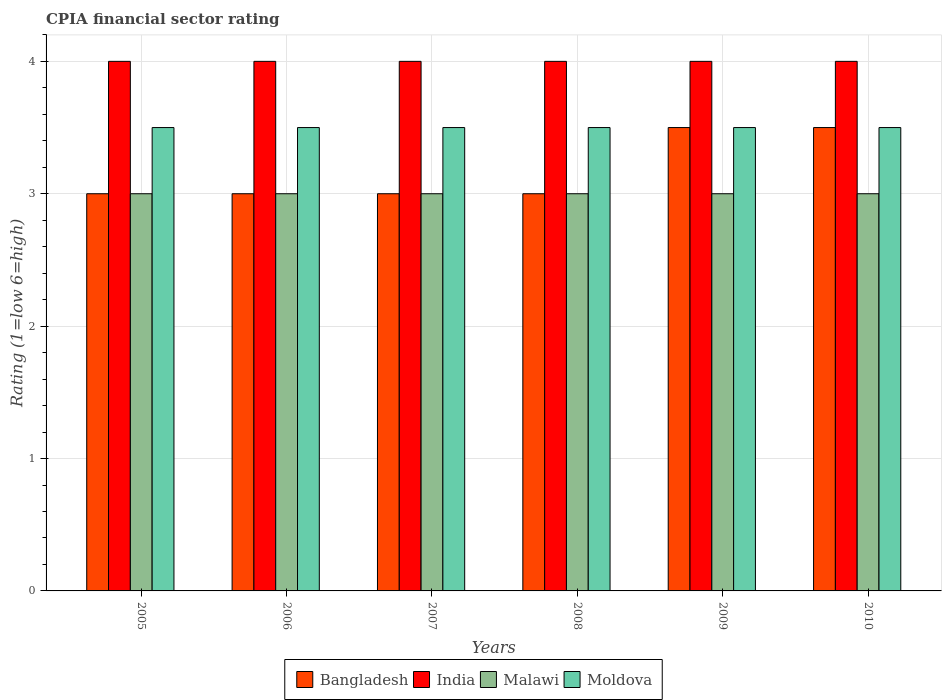Are the number of bars on each tick of the X-axis equal?
Your answer should be compact. Yes. How many bars are there on the 4th tick from the right?
Offer a terse response. 4. What is the CPIA rating in Moldova in 2007?
Give a very brief answer. 3.5. Across all years, what is the minimum CPIA rating in Bangladesh?
Ensure brevity in your answer.  3. In which year was the CPIA rating in Bangladesh maximum?
Your answer should be compact. 2009. What is the total CPIA rating in Bangladesh in the graph?
Your answer should be very brief. 19. What is the average CPIA rating in India per year?
Offer a terse response. 4. In the year 2005, what is the difference between the CPIA rating in Bangladesh and CPIA rating in Malawi?
Provide a short and direct response. 0. In how many years, is the CPIA rating in India greater than 1.8?
Offer a terse response. 6. What is the ratio of the CPIA rating in Bangladesh in 2006 to that in 2010?
Ensure brevity in your answer.  0.86. Is the difference between the CPIA rating in Bangladesh in 2009 and 2010 greater than the difference between the CPIA rating in Malawi in 2009 and 2010?
Offer a very short reply. No. Is the sum of the CPIA rating in Malawi in 2007 and 2010 greater than the maximum CPIA rating in India across all years?
Your response must be concise. Yes. Is it the case that in every year, the sum of the CPIA rating in Bangladesh and CPIA rating in Malawi is greater than the sum of CPIA rating in Moldova and CPIA rating in India?
Provide a short and direct response. No. What does the 4th bar from the left in 2008 represents?
Make the answer very short. Moldova. What does the 2nd bar from the right in 2010 represents?
Give a very brief answer. Malawi. Is it the case that in every year, the sum of the CPIA rating in Bangladesh and CPIA rating in India is greater than the CPIA rating in Malawi?
Offer a terse response. Yes. How many bars are there?
Make the answer very short. 24. Are the values on the major ticks of Y-axis written in scientific E-notation?
Your answer should be very brief. No. How many legend labels are there?
Give a very brief answer. 4. What is the title of the graph?
Offer a very short reply. CPIA financial sector rating. Does "Paraguay" appear as one of the legend labels in the graph?
Your answer should be compact. No. What is the label or title of the X-axis?
Provide a succinct answer. Years. What is the label or title of the Y-axis?
Make the answer very short. Rating (1=low 6=high). What is the Rating (1=low 6=high) in Bangladesh in 2005?
Keep it short and to the point. 3. What is the Rating (1=low 6=high) in Moldova in 2005?
Offer a very short reply. 3.5. What is the Rating (1=low 6=high) in India in 2006?
Offer a very short reply. 4. What is the Rating (1=low 6=high) of Malawi in 2006?
Your answer should be compact. 3. What is the Rating (1=low 6=high) in Moldova in 2006?
Keep it short and to the point. 3.5. What is the Rating (1=low 6=high) of India in 2007?
Keep it short and to the point. 4. What is the Rating (1=low 6=high) in Bangladesh in 2008?
Keep it short and to the point. 3. What is the Rating (1=low 6=high) of Bangladesh in 2009?
Offer a very short reply. 3.5. What is the Rating (1=low 6=high) of Malawi in 2009?
Give a very brief answer. 3. What is the Rating (1=low 6=high) in Moldova in 2009?
Offer a very short reply. 3.5. What is the Rating (1=low 6=high) in Bangladesh in 2010?
Provide a succinct answer. 3.5. What is the Rating (1=low 6=high) in India in 2010?
Give a very brief answer. 4. What is the Rating (1=low 6=high) of Malawi in 2010?
Provide a short and direct response. 3. Across all years, what is the maximum Rating (1=low 6=high) in India?
Keep it short and to the point. 4. Across all years, what is the minimum Rating (1=low 6=high) in Bangladesh?
Your answer should be very brief. 3. Across all years, what is the minimum Rating (1=low 6=high) of Malawi?
Your response must be concise. 3. Across all years, what is the minimum Rating (1=low 6=high) in Moldova?
Your answer should be very brief. 3.5. What is the total Rating (1=low 6=high) in Bangladesh in the graph?
Give a very brief answer. 19. What is the total Rating (1=low 6=high) of India in the graph?
Your answer should be very brief. 24. What is the total Rating (1=low 6=high) in Malawi in the graph?
Your answer should be compact. 18. What is the difference between the Rating (1=low 6=high) of Bangladesh in 2005 and that in 2006?
Your response must be concise. 0. What is the difference between the Rating (1=low 6=high) in India in 2005 and that in 2006?
Offer a very short reply. 0. What is the difference between the Rating (1=low 6=high) of Malawi in 2005 and that in 2007?
Offer a terse response. 0. What is the difference between the Rating (1=low 6=high) in Bangladesh in 2005 and that in 2008?
Keep it short and to the point. 0. What is the difference between the Rating (1=low 6=high) of India in 2005 and that in 2008?
Your response must be concise. 0. What is the difference between the Rating (1=low 6=high) in Malawi in 2005 and that in 2008?
Make the answer very short. 0. What is the difference between the Rating (1=low 6=high) of Malawi in 2005 and that in 2009?
Give a very brief answer. 0. What is the difference between the Rating (1=low 6=high) in Moldova in 2005 and that in 2009?
Offer a very short reply. 0. What is the difference between the Rating (1=low 6=high) in India in 2005 and that in 2010?
Your response must be concise. 0. What is the difference between the Rating (1=low 6=high) of Malawi in 2005 and that in 2010?
Your answer should be very brief. 0. What is the difference between the Rating (1=low 6=high) in Bangladesh in 2006 and that in 2007?
Your answer should be very brief. 0. What is the difference between the Rating (1=low 6=high) in India in 2006 and that in 2007?
Give a very brief answer. 0. What is the difference between the Rating (1=low 6=high) of Malawi in 2006 and that in 2007?
Your answer should be very brief. 0. What is the difference between the Rating (1=low 6=high) in Bangladesh in 2006 and that in 2008?
Your answer should be compact. 0. What is the difference between the Rating (1=low 6=high) of India in 2006 and that in 2008?
Provide a short and direct response. 0. What is the difference between the Rating (1=low 6=high) in Malawi in 2006 and that in 2008?
Offer a terse response. 0. What is the difference between the Rating (1=low 6=high) of Malawi in 2006 and that in 2009?
Make the answer very short. 0. What is the difference between the Rating (1=low 6=high) of Moldova in 2006 and that in 2010?
Keep it short and to the point. 0. What is the difference between the Rating (1=low 6=high) of India in 2007 and that in 2008?
Provide a succinct answer. 0. What is the difference between the Rating (1=low 6=high) in Malawi in 2007 and that in 2008?
Your answer should be compact. 0. What is the difference between the Rating (1=low 6=high) of Moldova in 2007 and that in 2008?
Give a very brief answer. 0. What is the difference between the Rating (1=low 6=high) of Bangladesh in 2007 and that in 2009?
Provide a succinct answer. -0.5. What is the difference between the Rating (1=low 6=high) in Moldova in 2007 and that in 2009?
Provide a short and direct response. 0. What is the difference between the Rating (1=low 6=high) in India in 2007 and that in 2010?
Provide a short and direct response. 0. What is the difference between the Rating (1=low 6=high) of Malawi in 2007 and that in 2010?
Keep it short and to the point. 0. What is the difference between the Rating (1=low 6=high) in Moldova in 2007 and that in 2010?
Offer a terse response. 0. What is the difference between the Rating (1=low 6=high) of Bangladesh in 2008 and that in 2009?
Make the answer very short. -0.5. What is the difference between the Rating (1=low 6=high) in India in 2008 and that in 2009?
Provide a short and direct response. 0. What is the difference between the Rating (1=low 6=high) of Malawi in 2008 and that in 2009?
Offer a very short reply. 0. What is the difference between the Rating (1=low 6=high) of Moldova in 2008 and that in 2009?
Your answer should be very brief. 0. What is the difference between the Rating (1=low 6=high) in Malawi in 2008 and that in 2010?
Offer a very short reply. 0. What is the difference between the Rating (1=low 6=high) in Moldova in 2008 and that in 2010?
Keep it short and to the point. 0. What is the difference between the Rating (1=low 6=high) in Bangladesh in 2009 and that in 2010?
Your answer should be very brief. 0. What is the difference between the Rating (1=low 6=high) in India in 2009 and that in 2010?
Ensure brevity in your answer.  0. What is the difference between the Rating (1=low 6=high) in Malawi in 2009 and that in 2010?
Keep it short and to the point. 0. What is the difference between the Rating (1=low 6=high) in Bangladesh in 2005 and the Rating (1=low 6=high) in India in 2006?
Ensure brevity in your answer.  -1. What is the difference between the Rating (1=low 6=high) of Bangladesh in 2005 and the Rating (1=low 6=high) of Malawi in 2006?
Ensure brevity in your answer.  0. What is the difference between the Rating (1=low 6=high) of Bangladesh in 2005 and the Rating (1=low 6=high) of Moldova in 2006?
Your answer should be compact. -0.5. What is the difference between the Rating (1=low 6=high) in India in 2005 and the Rating (1=low 6=high) in Malawi in 2006?
Your answer should be very brief. 1. What is the difference between the Rating (1=low 6=high) of India in 2005 and the Rating (1=low 6=high) of Moldova in 2006?
Your answer should be compact. 0.5. What is the difference between the Rating (1=low 6=high) of Bangladesh in 2005 and the Rating (1=low 6=high) of Malawi in 2007?
Offer a very short reply. 0. What is the difference between the Rating (1=low 6=high) in Bangladesh in 2005 and the Rating (1=low 6=high) in Moldova in 2007?
Ensure brevity in your answer.  -0.5. What is the difference between the Rating (1=low 6=high) of Bangladesh in 2005 and the Rating (1=low 6=high) of India in 2008?
Keep it short and to the point. -1. What is the difference between the Rating (1=low 6=high) of Bangladesh in 2005 and the Rating (1=low 6=high) of Malawi in 2008?
Give a very brief answer. 0. What is the difference between the Rating (1=low 6=high) of Bangladesh in 2005 and the Rating (1=low 6=high) of Moldova in 2008?
Your answer should be compact. -0.5. What is the difference between the Rating (1=low 6=high) in India in 2005 and the Rating (1=low 6=high) in Malawi in 2008?
Keep it short and to the point. 1. What is the difference between the Rating (1=low 6=high) of India in 2005 and the Rating (1=low 6=high) of Moldova in 2008?
Your response must be concise. 0.5. What is the difference between the Rating (1=low 6=high) in Bangladesh in 2005 and the Rating (1=low 6=high) in India in 2009?
Make the answer very short. -1. What is the difference between the Rating (1=low 6=high) of Bangladesh in 2005 and the Rating (1=low 6=high) of Malawi in 2009?
Give a very brief answer. 0. What is the difference between the Rating (1=low 6=high) in Malawi in 2005 and the Rating (1=low 6=high) in Moldova in 2009?
Provide a short and direct response. -0.5. What is the difference between the Rating (1=low 6=high) in India in 2005 and the Rating (1=low 6=high) in Malawi in 2010?
Provide a succinct answer. 1. What is the difference between the Rating (1=low 6=high) in India in 2005 and the Rating (1=low 6=high) in Moldova in 2010?
Your response must be concise. 0.5. What is the difference between the Rating (1=low 6=high) of Bangladesh in 2006 and the Rating (1=low 6=high) of India in 2007?
Keep it short and to the point. -1. What is the difference between the Rating (1=low 6=high) in Bangladesh in 2006 and the Rating (1=low 6=high) in Malawi in 2007?
Your answer should be compact. 0. What is the difference between the Rating (1=low 6=high) in Bangladesh in 2006 and the Rating (1=low 6=high) in Moldova in 2007?
Give a very brief answer. -0.5. What is the difference between the Rating (1=low 6=high) in India in 2006 and the Rating (1=low 6=high) in Malawi in 2007?
Offer a very short reply. 1. What is the difference between the Rating (1=low 6=high) of Malawi in 2006 and the Rating (1=low 6=high) of Moldova in 2007?
Give a very brief answer. -0.5. What is the difference between the Rating (1=low 6=high) of Bangladesh in 2006 and the Rating (1=low 6=high) of Malawi in 2008?
Provide a succinct answer. 0. What is the difference between the Rating (1=low 6=high) of India in 2006 and the Rating (1=low 6=high) of Moldova in 2008?
Keep it short and to the point. 0.5. What is the difference between the Rating (1=low 6=high) of Malawi in 2006 and the Rating (1=low 6=high) of Moldova in 2008?
Provide a succinct answer. -0.5. What is the difference between the Rating (1=low 6=high) of Bangladesh in 2006 and the Rating (1=low 6=high) of India in 2009?
Keep it short and to the point. -1. What is the difference between the Rating (1=low 6=high) of Bangladesh in 2006 and the Rating (1=low 6=high) of Moldova in 2009?
Your response must be concise. -0.5. What is the difference between the Rating (1=low 6=high) in India in 2006 and the Rating (1=low 6=high) in Malawi in 2009?
Ensure brevity in your answer.  1. What is the difference between the Rating (1=low 6=high) in Malawi in 2006 and the Rating (1=low 6=high) in Moldova in 2009?
Keep it short and to the point. -0.5. What is the difference between the Rating (1=low 6=high) in India in 2006 and the Rating (1=low 6=high) in Moldova in 2010?
Keep it short and to the point. 0.5. What is the difference between the Rating (1=low 6=high) in Bangladesh in 2007 and the Rating (1=low 6=high) in India in 2008?
Provide a short and direct response. -1. What is the difference between the Rating (1=low 6=high) of Bangladesh in 2007 and the Rating (1=low 6=high) of Malawi in 2008?
Offer a very short reply. 0. What is the difference between the Rating (1=low 6=high) of Malawi in 2007 and the Rating (1=low 6=high) of Moldova in 2008?
Make the answer very short. -0.5. What is the difference between the Rating (1=low 6=high) in Bangladesh in 2007 and the Rating (1=low 6=high) in India in 2009?
Offer a terse response. -1. What is the difference between the Rating (1=low 6=high) of Bangladesh in 2007 and the Rating (1=low 6=high) of India in 2010?
Offer a very short reply. -1. What is the difference between the Rating (1=low 6=high) in Bangladesh in 2007 and the Rating (1=low 6=high) in Malawi in 2010?
Offer a very short reply. 0. What is the difference between the Rating (1=low 6=high) of India in 2007 and the Rating (1=low 6=high) of Malawi in 2010?
Your answer should be very brief. 1. What is the difference between the Rating (1=low 6=high) of Bangladesh in 2008 and the Rating (1=low 6=high) of India in 2009?
Your answer should be very brief. -1. What is the difference between the Rating (1=low 6=high) in Bangladesh in 2008 and the Rating (1=low 6=high) in India in 2010?
Provide a succinct answer. -1. What is the difference between the Rating (1=low 6=high) of Bangladesh in 2008 and the Rating (1=low 6=high) of Malawi in 2010?
Provide a short and direct response. 0. What is the difference between the Rating (1=low 6=high) of Bangladesh in 2008 and the Rating (1=low 6=high) of Moldova in 2010?
Your answer should be very brief. -0.5. What is the difference between the Rating (1=low 6=high) of Malawi in 2008 and the Rating (1=low 6=high) of Moldova in 2010?
Keep it short and to the point. -0.5. What is the difference between the Rating (1=low 6=high) of Bangladesh in 2009 and the Rating (1=low 6=high) of India in 2010?
Provide a succinct answer. -0.5. What is the difference between the Rating (1=low 6=high) in Bangladesh in 2009 and the Rating (1=low 6=high) in Malawi in 2010?
Your response must be concise. 0.5. What is the difference between the Rating (1=low 6=high) in Bangladesh in 2009 and the Rating (1=low 6=high) in Moldova in 2010?
Your answer should be compact. 0. What is the difference between the Rating (1=low 6=high) of India in 2009 and the Rating (1=low 6=high) of Moldova in 2010?
Your answer should be compact. 0.5. What is the average Rating (1=low 6=high) in Bangladesh per year?
Provide a succinct answer. 3.17. What is the average Rating (1=low 6=high) in Malawi per year?
Give a very brief answer. 3. In the year 2005, what is the difference between the Rating (1=low 6=high) in Bangladesh and Rating (1=low 6=high) in Malawi?
Your response must be concise. 0. In the year 2005, what is the difference between the Rating (1=low 6=high) in Bangladesh and Rating (1=low 6=high) in Moldova?
Your response must be concise. -0.5. In the year 2005, what is the difference between the Rating (1=low 6=high) in India and Rating (1=low 6=high) in Moldova?
Your answer should be very brief. 0.5. In the year 2005, what is the difference between the Rating (1=low 6=high) in Malawi and Rating (1=low 6=high) in Moldova?
Ensure brevity in your answer.  -0.5. In the year 2007, what is the difference between the Rating (1=low 6=high) of Bangladesh and Rating (1=low 6=high) of Malawi?
Keep it short and to the point. 0. In the year 2007, what is the difference between the Rating (1=low 6=high) in Bangladesh and Rating (1=low 6=high) in Moldova?
Your answer should be compact. -0.5. In the year 2007, what is the difference between the Rating (1=low 6=high) of India and Rating (1=low 6=high) of Moldova?
Offer a very short reply. 0.5. In the year 2007, what is the difference between the Rating (1=low 6=high) in Malawi and Rating (1=low 6=high) in Moldova?
Your answer should be compact. -0.5. In the year 2008, what is the difference between the Rating (1=low 6=high) in Bangladesh and Rating (1=low 6=high) in India?
Provide a succinct answer. -1. In the year 2008, what is the difference between the Rating (1=low 6=high) of India and Rating (1=low 6=high) of Moldova?
Offer a very short reply. 0.5. In the year 2009, what is the difference between the Rating (1=low 6=high) of India and Rating (1=low 6=high) of Malawi?
Ensure brevity in your answer.  1. In the year 2009, what is the difference between the Rating (1=low 6=high) in Malawi and Rating (1=low 6=high) in Moldova?
Your answer should be very brief. -0.5. In the year 2010, what is the difference between the Rating (1=low 6=high) in India and Rating (1=low 6=high) in Malawi?
Your response must be concise. 1. In the year 2010, what is the difference between the Rating (1=low 6=high) in India and Rating (1=low 6=high) in Moldova?
Ensure brevity in your answer.  0.5. In the year 2010, what is the difference between the Rating (1=low 6=high) of Malawi and Rating (1=low 6=high) of Moldova?
Ensure brevity in your answer.  -0.5. What is the ratio of the Rating (1=low 6=high) of Moldova in 2005 to that in 2006?
Provide a succinct answer. 1. What is the ratio of the Rating (1=low 6=high) in Bangladesh in 2005 to that in 2007?
Provide a short and direct response. 1. What is the ratio of the Rating (1=low 6=high) in Moldova in 2005 to that in 2007?
Provide a short and direct response. 1. What is the ratio of the Rating (1=low 6=high) of Bangladesh in 2005 to that in 2008?
Keep it short and to the point. 1. What is the ratio of the Rating (1=low 6=high) in Malawi in 2005 to that in 2009?
Offer a very short reply. 1. What is the ratio of the Rating (1=low 6=high) of Moldova in 2005 to that in 2009?
Your answer should be compact. 1. What is the ratio of the Rating (1=low 6=high) in Moldova in 2005 to that in 2010?
Offer a very short reply. 1. What is the ratio of the Rating (1=low 6=high) in Moldova in 2006 to that in 2007?
Your answer should be very brief. 1. What is the ratio of the Rating (1=low 6=high) of Malawi in 2006 to that in 2008?
Ensure brevity in your answer.  1. What is the ratio of the Rating (1=low 6=high) in Bangladesh in 2006 to that in 2009?
Provide a short and direct response. 0.86. What is the ratio of the Rating (1=low 6=high) in India in 2006 to that in 2009?
Provide a succinct answer. 1. What is the ratio of the Rating (1=low 6=high) in India in 2006 to that in 2010?
Offer a terse response. 1. What is the ratio of the Rating (1=low 6=high) of Moldova in 2006 to that in 2010?
Provide a short and direct response. 1. What is the ratio of the Rating (1=low 6=high) in Bangladesh in 2007 to that in 2008?
Your response must be concise. 1. What is the ratio of the Rating (1=low 6=high) in Moldova in 2007 to that in 2008?
Ensure brevity in your answer.  1. What is the ratio of the Rating (1=low 6=high) in Malawi in 2007 to that in 2009?
Keep it short and to the point. 1. What is the ratio of the Rating (1=low 6=high) in Moldova in 2007 to that in 2009?
Offer a very short reply. 1. What is the ratio of the Rating (1=low 6=high) in Malawi in 2007 to that in 2010?
Make the answer very short. 1. What is the ratio of the Rating (1=low 6=high) in Moldova in 2007 to that in 2010?
Offer a terse response. 1. What is the ratio of the Rating (1=low 6=high) in Malawi in 2008 to that in 2009?
Provide a short and direct response. 1. What is the ratio of the Rating (1=low 6=high) of Bangladesh in 2008 to that in 2010?
Your answer should be compact. 0.86. What is the ratio of the Rating (1=low 6=high) in India in 2008 to that in 2010?
Provide a succinct answer. 1. What is the ratio of the Rating (1=low 6=high) of Malawi in 2008 to that in 2010?
Offer a terse response. 1. What is the ratio of the Rating (1=low 6=high) of Moldova in 2008 to that in 2010?
Your answer should be very brief. 1. What is the ratio of the Rating (1=low 6=high) in Bangladesh in 2009 to that in 2010?
Your answer should be compact. 1. What is the ratio of the Rating (1=low 6=high) in Malawi in 2009 to that in 2010?
Ensure brevity in your answer.  1. What is the ratio of the Rating (1=low 6=high) of Moldova in 2009 to that in 2010?
Keep it short and to the point. 1. What is the difference between the highest and the second highest Rating (1=low 6=high) of Bangladesh?
Keep it short and to the point. 0. What is the difference between the highest and the lowest Rating (1=low 6=high) in Bangladesh?
Your response must be concise. 0.5. What is the difference between the highest and the lowest Rating (1=low 6=high) of India?
Give a very brief answer. 0. What is the difference between the highest and the lowest Rating (1=low 6=high) in Malawi?
Offer a terse response. 0. What is the difference between the highest and the lowest Rating (1=low 6=high) of Moldova?
Provide a short and direct response. 0. 